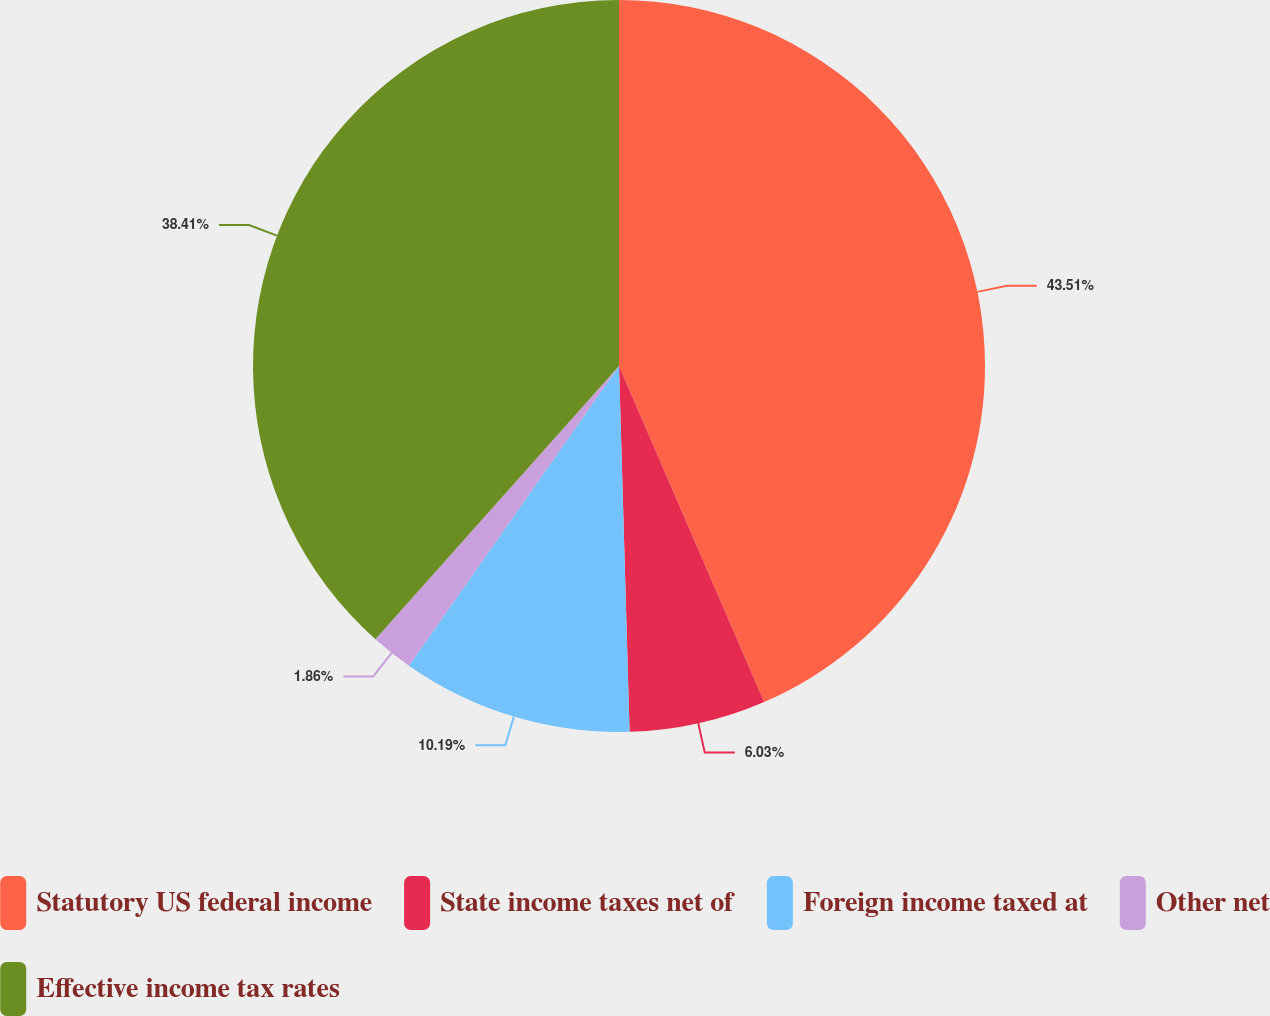Convert chart to OTSL. <chart><loc_0><loc_0><loc_500><loc_500><pie_chart><fcel>Statutory US federal income<fcel>State income taxes net of<fcel>Foreign income taxed at<fcel>Other net<fcel>Effective income tax rates<nl><fcel>43.51%<fcel>6.03%<fcel>10.19%<fcel>1.86%<fcel>38.41%<nl></chart> 